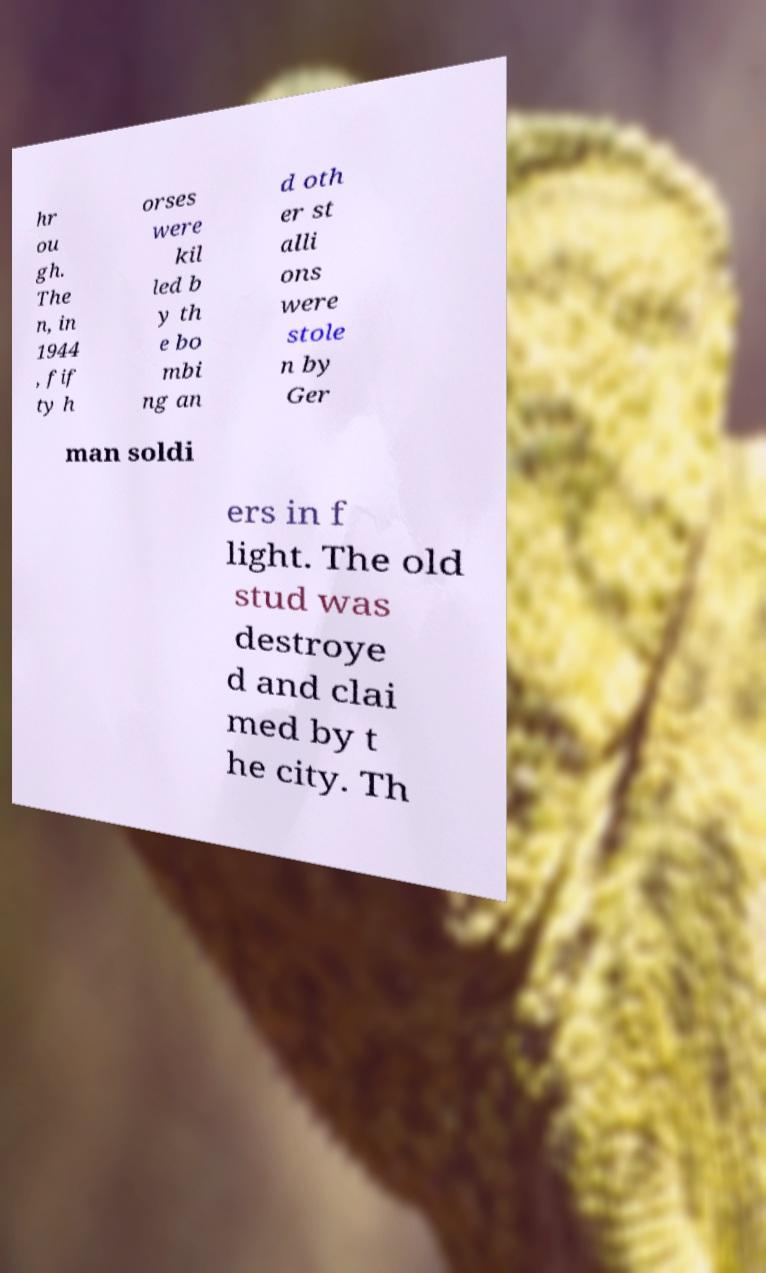Can you read and provide the text displayed in the image?This photo seems to have some interesting text. Can you extract and type it out for me? hr ou gh. The n, in 1944 , fif ty h orses were kil led b y th e bo mbi ng an d oth er st alli ons were stole n by Ger man soldi ers in f light. The old stud was destroye d and clai med by t he city. Th 